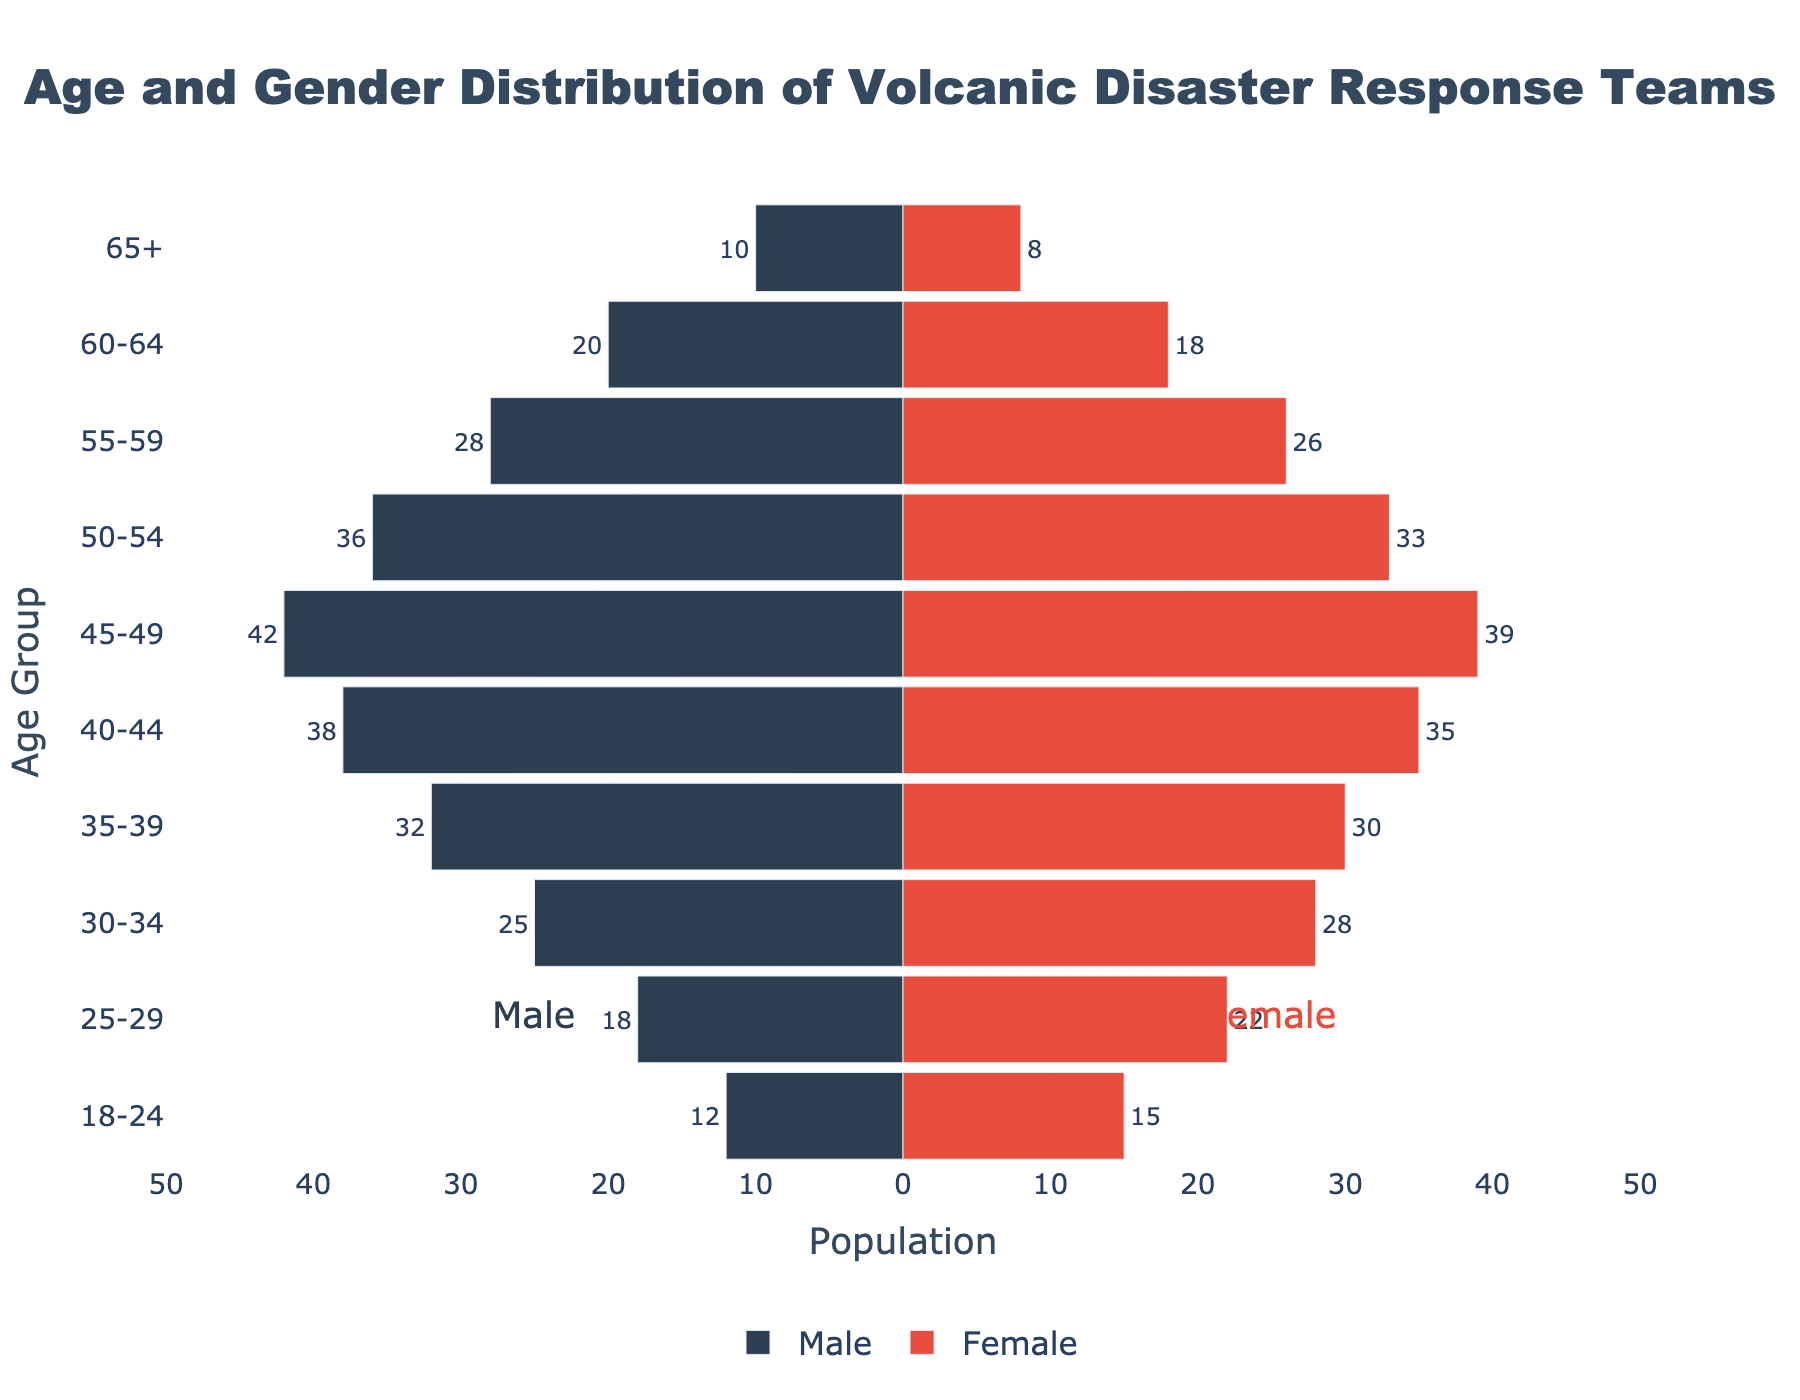What's the title of the figure? The title is located at the top of the figure and usually gives a clear idea of what the plot is about.
Answer: Age and Gender Distribution of Volcanic Disaster Response Teams What's the age group with the largest number of females? Referring to the female bar lengths across different age groups and identifying the one with the longest bar provides the answer. For females, the bar for the age group '35-39' is the longest.
Answer: 35-39 What's the total number of males in the 45-49 and 50-54 age groups? Sum the values corresponding to the 45-49 and 50-54 age groups for males: 42 (45-49) + 36 (50-54) = 78
Answer: 78 Which age group has more males than females? By comparing the lengths of the bars for males and females for each age group, determine which ones have male bars longer than female bars. Multiple age groups meet the criteria here, where the male counts are higher than their corresponding female counts.
Answer: 35-39, 40-44, 45-49, 50-54, 55-59, 60-64, 65+ What’s the difference in number of people between the age group 25-29 and 65+ in females? Calculate the difference by subtracting the number of females in the 65+ age group (8) from the number in the 25-29 age group (22): 22 - 8 = 14
Answer: 14 How many total people (both genders) are in the 18-24 age group? Add the number of males and females in the 18-24 age group: 12 (Male) + 15 (Female) = 27
Answer: 27 Which age group has the smallest combined total population (males and females)? Calculate the sums for both genders in each age group and find the age group with the smallest sum. For '65+', it's 10 (Male) + 8 (Female) = 18, which is the smallest combined total.
Answer: 65+ What’s the average number of males in age groups 30-34, 35-39, and 40-44? Find the values for these age groups, sum them, and divide by the number of age groups: (25 + 32 + 38) / 3 = 95 / 3 ≈ 31.67
Answer: 31.67 Is the population pyramid symmetrical? By visually assessing the lengths of bars on both sides and their distributions, determine if there’s symmetry. Since there are noticeable variations and more males in several age groups, it’s not symmetrical.
Answer: No What’s the gender distribution for the age group 55-59? Refer to the bar lengths for the age group 55-59 and note the numbers: 28 for males and 26 for females.
Answer: 28 males, 26 females 